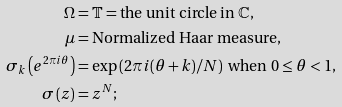Convert formula to latex. <formula><loc_0><loc_0><loc_500><loc_500>\Omega & = \mathbb { T } = \text {the unit circle in } \mathbb { C } , \\ \mu & = \text {Normalized Haar measure,} \\ \sigma _ { k } \left ( e ^ { 2 \pi i \theta } \right ) & = \exp \left ( 2 \pi i ( \theta + k ) / N \right ) \text { when } 0 \leq \theta < 1 , \\ \sigma \left ( z \right ) & = z ^ { N } ;</formula> 